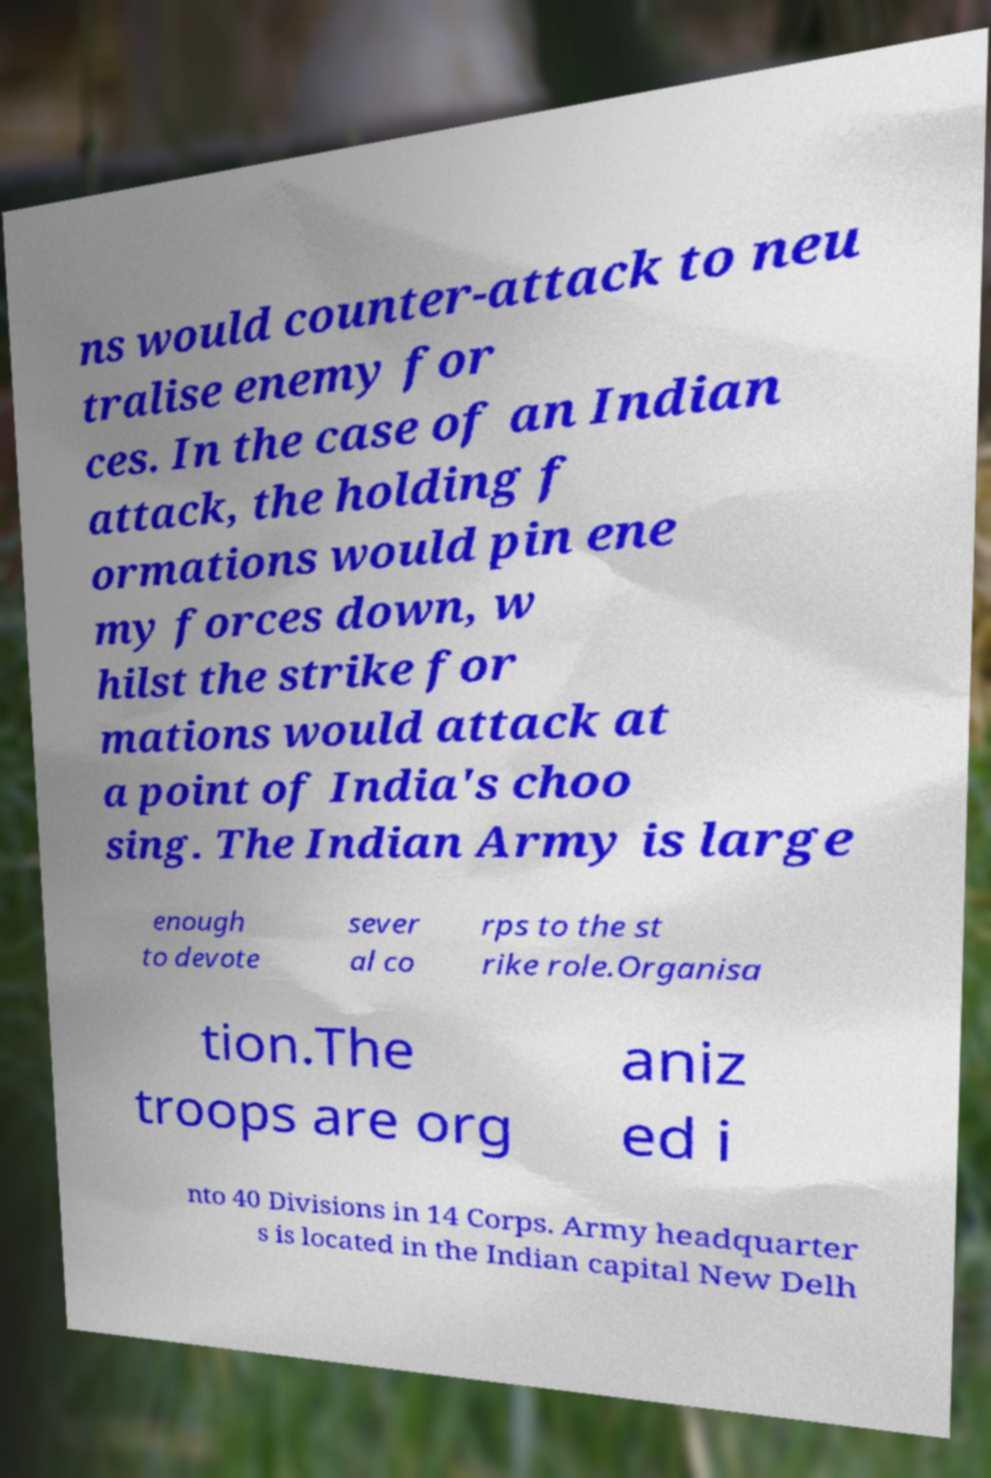Can you accurately transcribe the text from the provided image for me? ns would counter-attack to neu tralise enemy for ces. In the case of an Indian attack, the holding f ormations would pin ene my forces down, w hilst the strike for mations would attack at a point of India's choo sing. The Indian Army is large enough to devote sever al co rps to the st rike role.Organisa tion.The troops are org aniz ed i nto 40 Divisions in 14 Corps. Army headquarter s is located in the Indian capital New Delh 